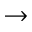Convert formula to latex. <formula><loc_0><loc_0><loc_500><loc_500>\rightarrow</formula> 